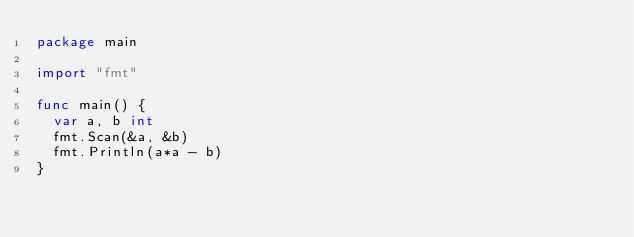<code> <loc_0><loc_0><loc_500><loc_500><_Go_>package main

import "fmt"

func main() {
	var a, b int
	fmt.Scan(&a, &b)
	fmt.Println(a*a - b)
}
</code> 